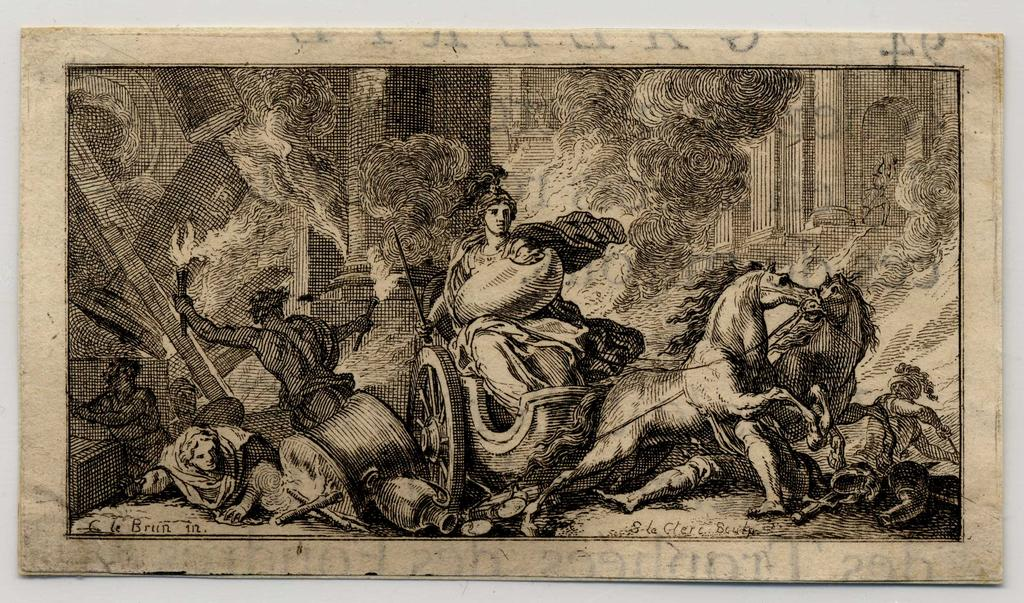What object can be seen in the image? There is a photo frame in the image. Where is the photo frame located? The photo frame is placed on a wall. What type of request is being made in the image? There is no request being made in the image; it only features a photo frame on a wall. 